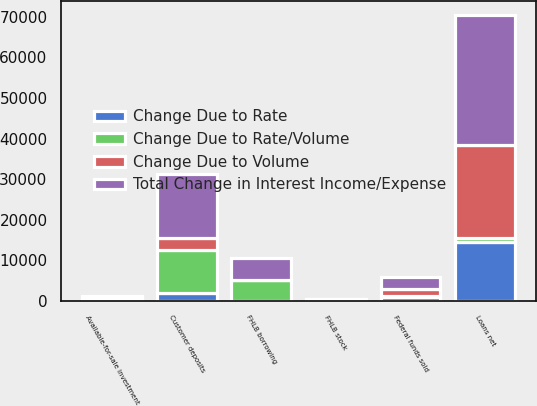<chart> <loc_0><loc_0><loc_500><loc_500><stacked_bar_chart><ecel><fcel>Loans net<fcel>Available-for-sale investment<fcel>Federal funds sold<fcel>FHLB stock<fcel>Customer deposits<fcel>FHLB borrowing<nl><fcel>Change Due to Rate/Volume<fcel>1016<fcel>458<fcel>234<fcel>303<fcel>10750<fcel>5176<nl><fcel>Change Due to Rate<fcel>14490<fcel>63<fcel>1016<fcel>153<fcel>1880<fcel>81<nl><fcel>Change Due to Volume<fcel>23027<fcel>133<fcel>1659<fcel>25<fcel>3004<fcel>13<nl><fcel>Total Change in Interest Income/Expense<fcel>31949<fcel>654<fcel>2909<fcel>125<fcel>15634<fcel>5270<nl></chart> 